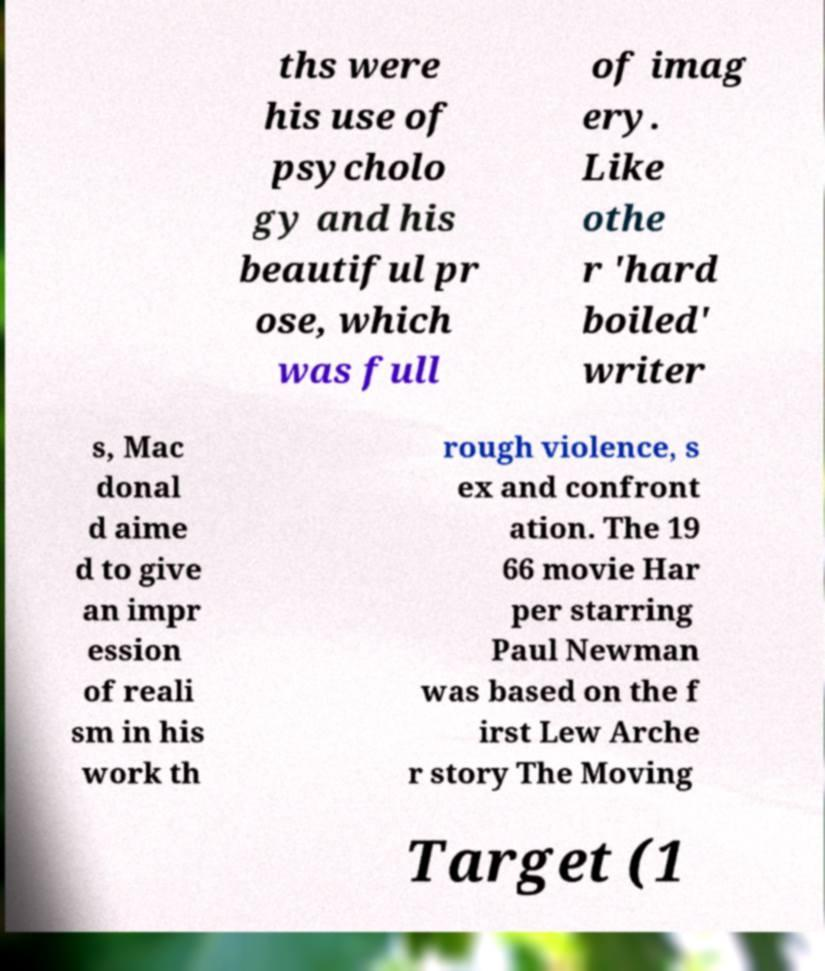Could you extract and type out the text from this image? ths were his use of psycholo gy and his beautiful pr ose, which was full of imag ery. Like othe r 'hard boiled' writer s, Mac donal d aime d to give an impr ession of reali sm in his work th rough violence, s ex and confront ation. The 19 66 movie Har per starring Paul Newman was based on the f irst Lew Arche r story The Moving Target (1 